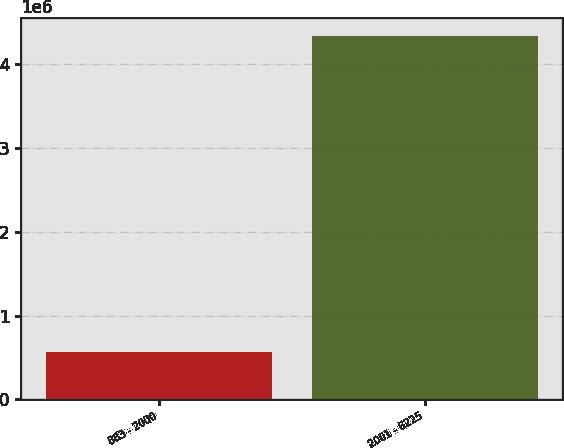<chart> <loc_0><loc_0><loc_500><loc_500><bar_chart><fcel>883 - 2000<fcel>2001 - 6225<nl><fcel>570080<fcel>4.33519e+06<nl></chart> 